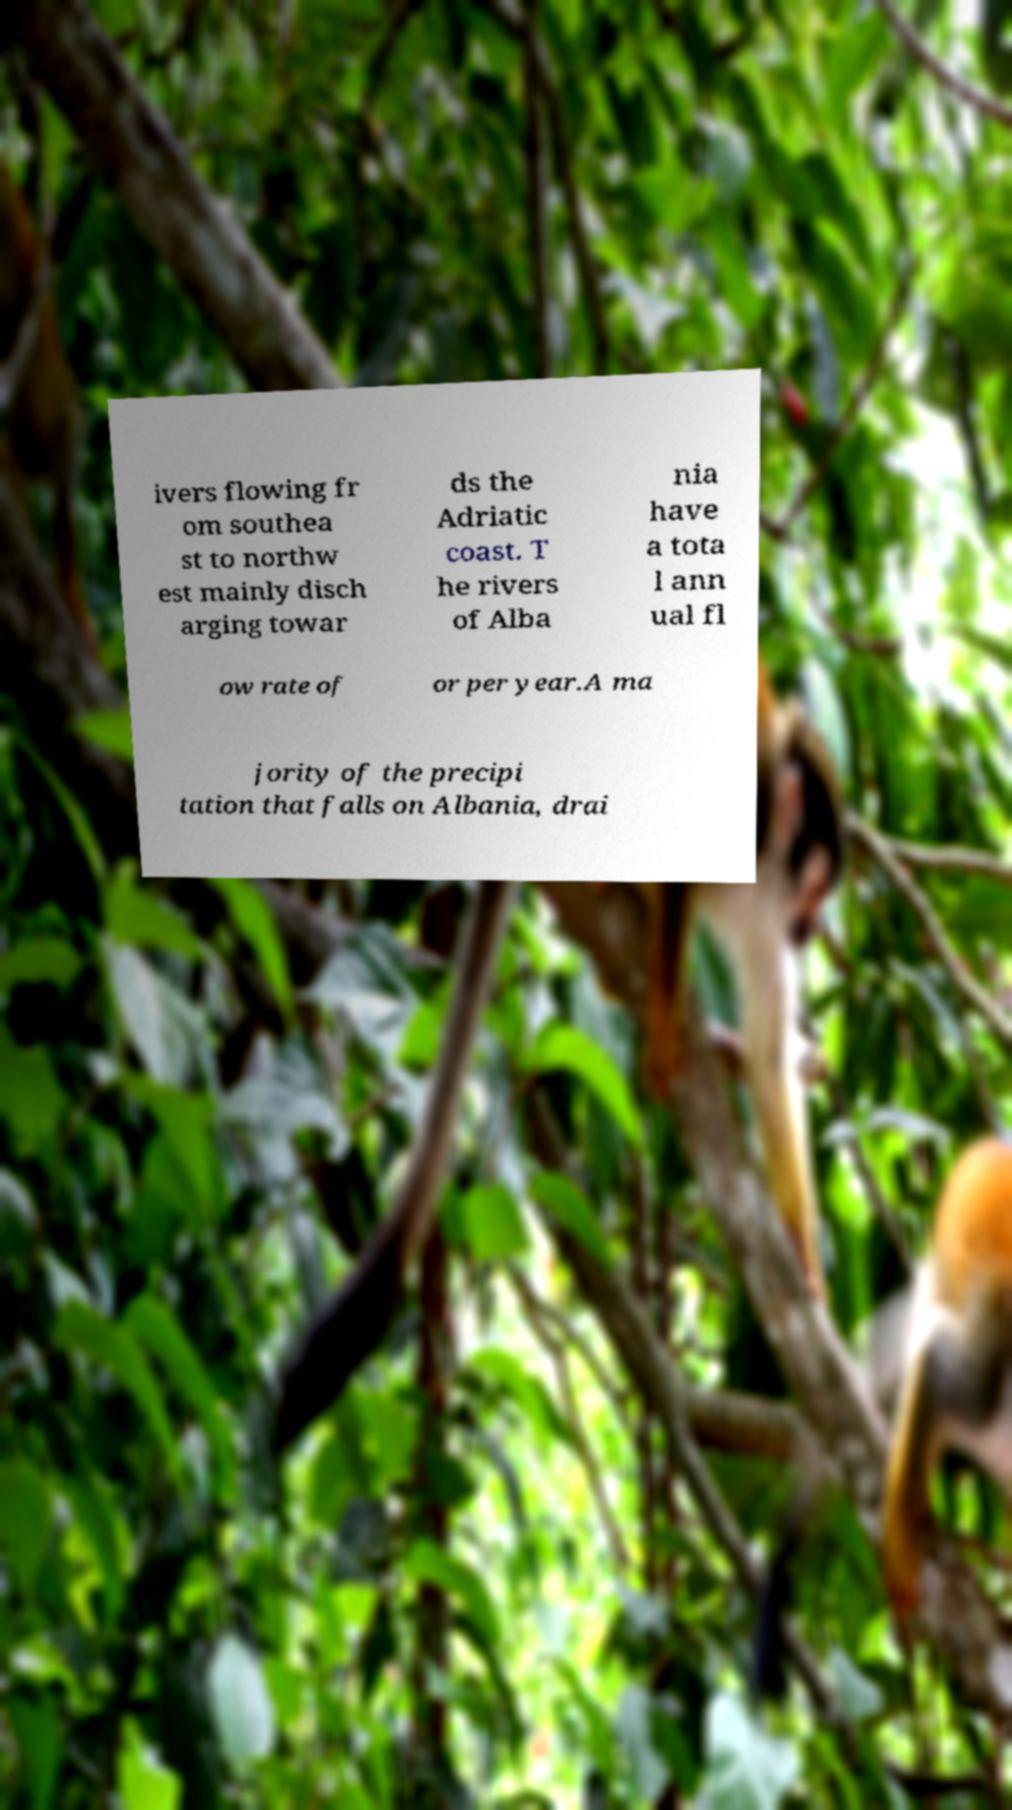There's text embedded in this image that I need extracted. Can you transcribe it verbatim? ivers flowing fr om southea st to northw est mainly disch arging towar ds the Adriatic coast. T he rivers of Alba nia have a tota l ann ual fl ow rate of or per year.A ma jority of the precipi tation that falls on Albania, drai 